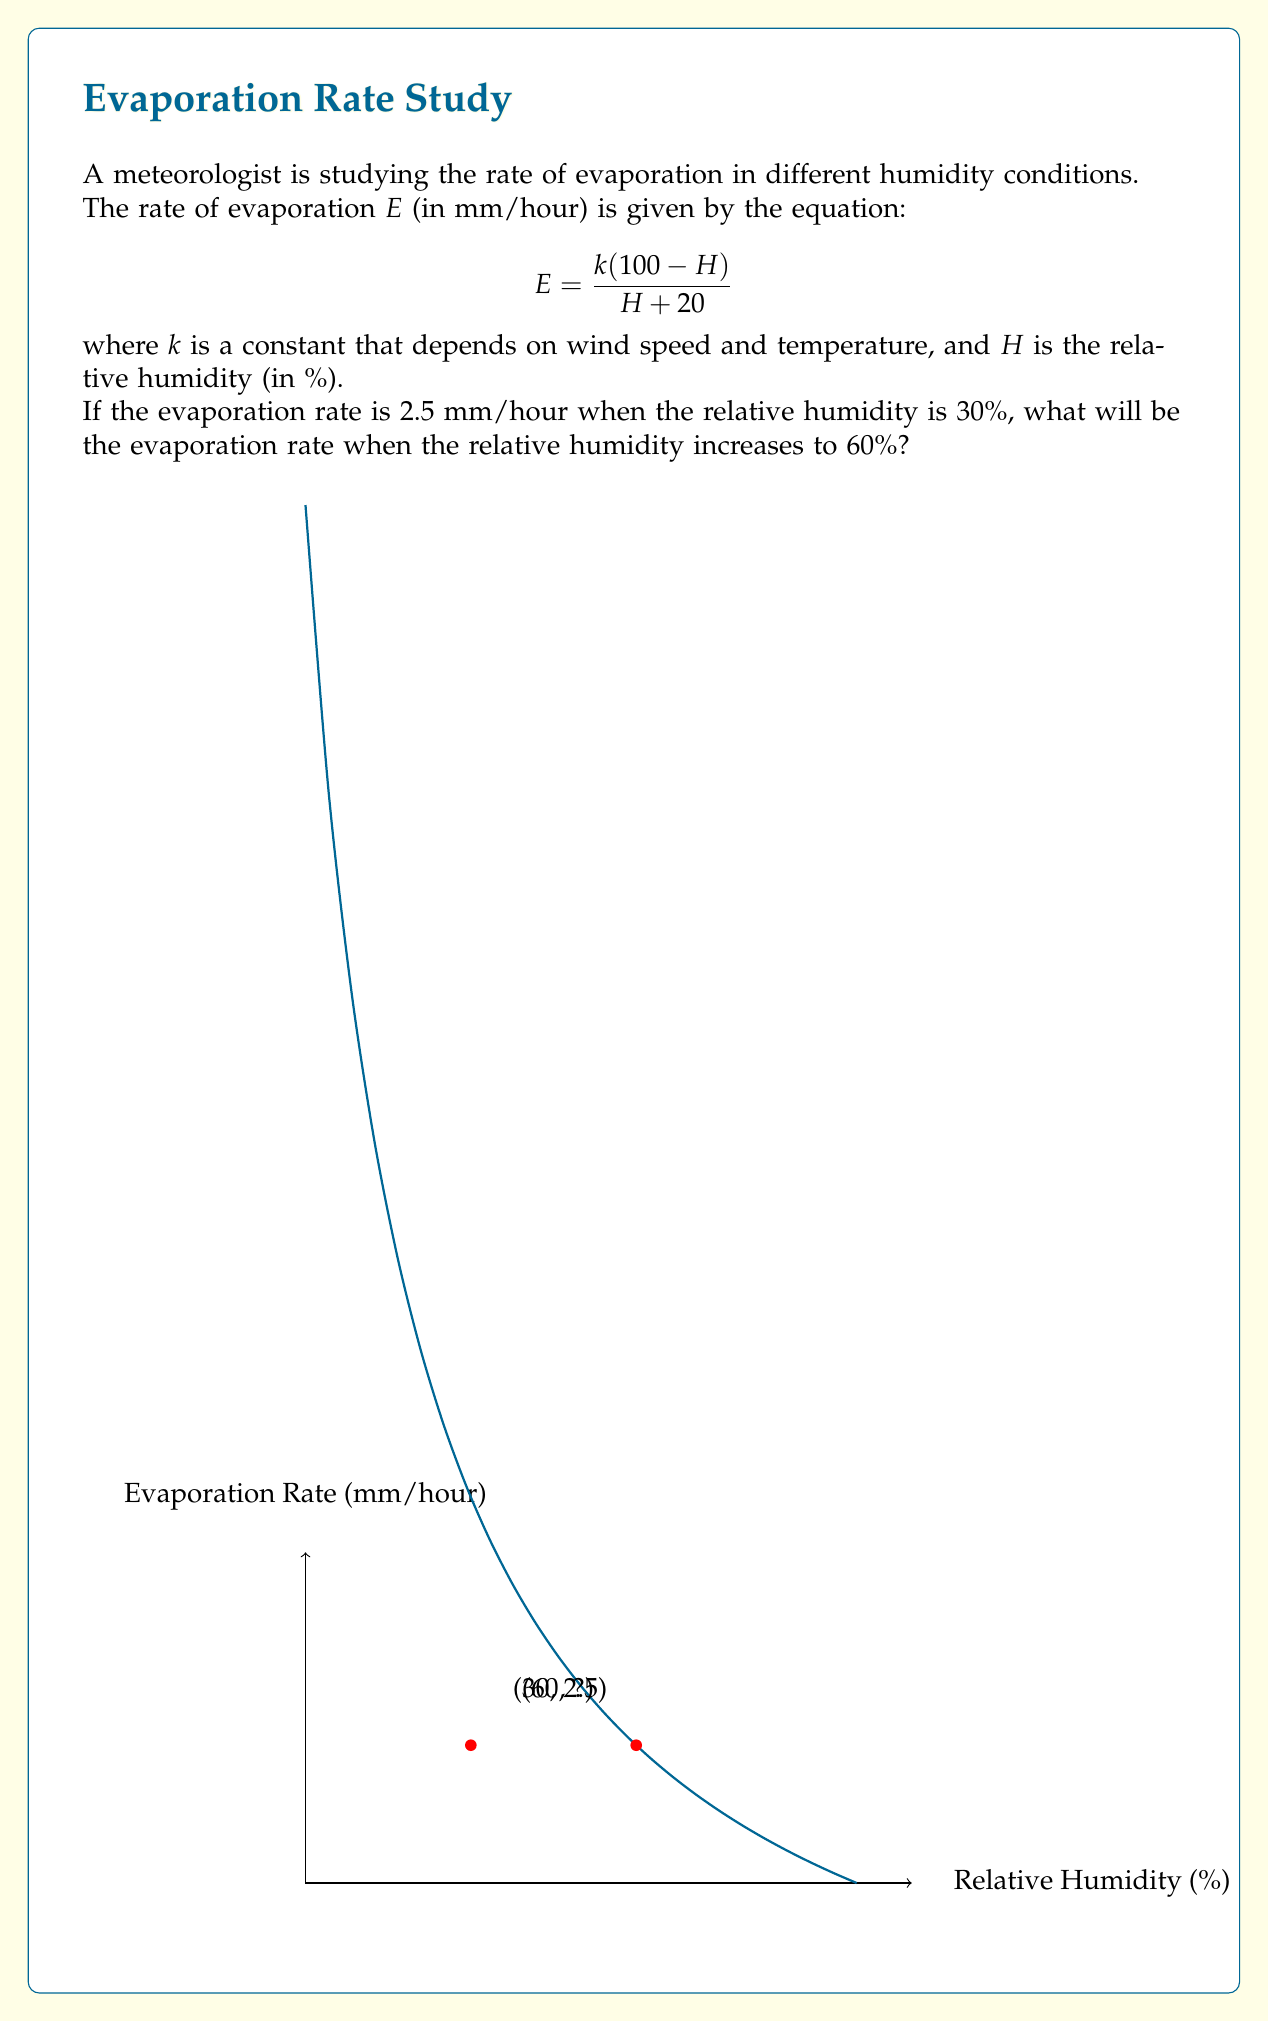What is the answer to this math problem? Let's solve this problem step by step:

1) First, we need to find the value of $k$ using the given information when $H = 30%$ and $E = 2.5$ mm/hour:

   $$2.5 = \frac{k(100 - 30)}{30 + 20}$$

2) Simplify:
   $$2.5 = \frac{70k}{50}$$

3) Multiply both sides by 50:
   $$125 = 70k$$

4) Solve for $k$:
   $$k = \frac{125}{70} = 1.7857$$

5) Now that we know $k$, we can use the equation to find $E$ when $H = 60%$:

   $$E = \frac{1.7857(100 - 60)}{60 + 20}$$

6) Simplify:
   $$E = \frac{1.7857 \times 40}{80} = \frac{71.428}{80}$$

7) Calculate the final result:
   $$E = 0.8928$$ mm/hour

Therefore, when the relative humidity increases to 60%, the evaporation rate will be approximately 0.8928 mm/hour.
Answer: $0.8928$ mm/hour 